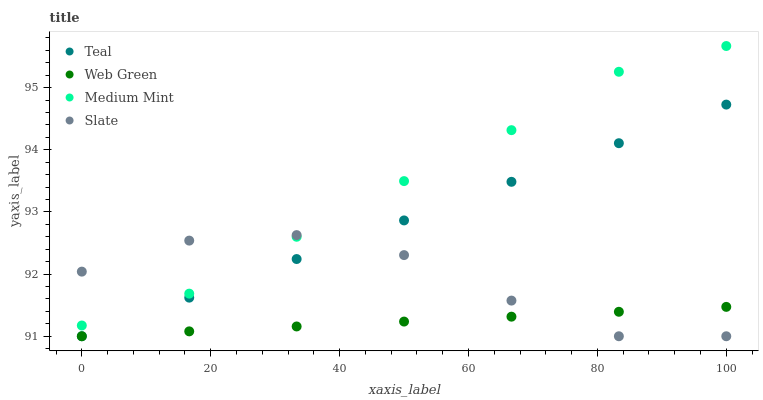Does Web Green have the minimum area under the curve?
Answer yes or no. Yes. Does Medium Mint have the maximum area under the curve?
Answer yes or no. Yes. Does Slate have the minimum area under the curve?
Answer yes or no. No. Does Slate have the maximum area under the curve?
Answer yes or no. No. Is Teal the smoothest?
Answer yes or no. Yes. Is Slate the roughest?
Answer yes or no. Yes. Is Web Green the smoothest?
Answer yes or no. No. Is Web Green the roughest?
Answer yes or no. No. Does Slate have the lowest value?
Answer yes or no. Yes. Does Medium Mint have the highest value?
Answer yes or no. Yes. Does Slate have the highest value?
Answer yes or no. No. Is Web Green less than Medium Mint?
Answer yes or no. Yes. Is Medium Mint greater than Web Green?
Answer yes or no. Yes. Does Slate intersect Medium Mint?
Answer yes or no. Yes. Is Slate less than Medium Mint?
Answer yes or no. No. Is Slate greater than Medium Mint?
Answer yes or no. No. Does Web Green intersect Medium Mint?
Answer yes or no. No. 